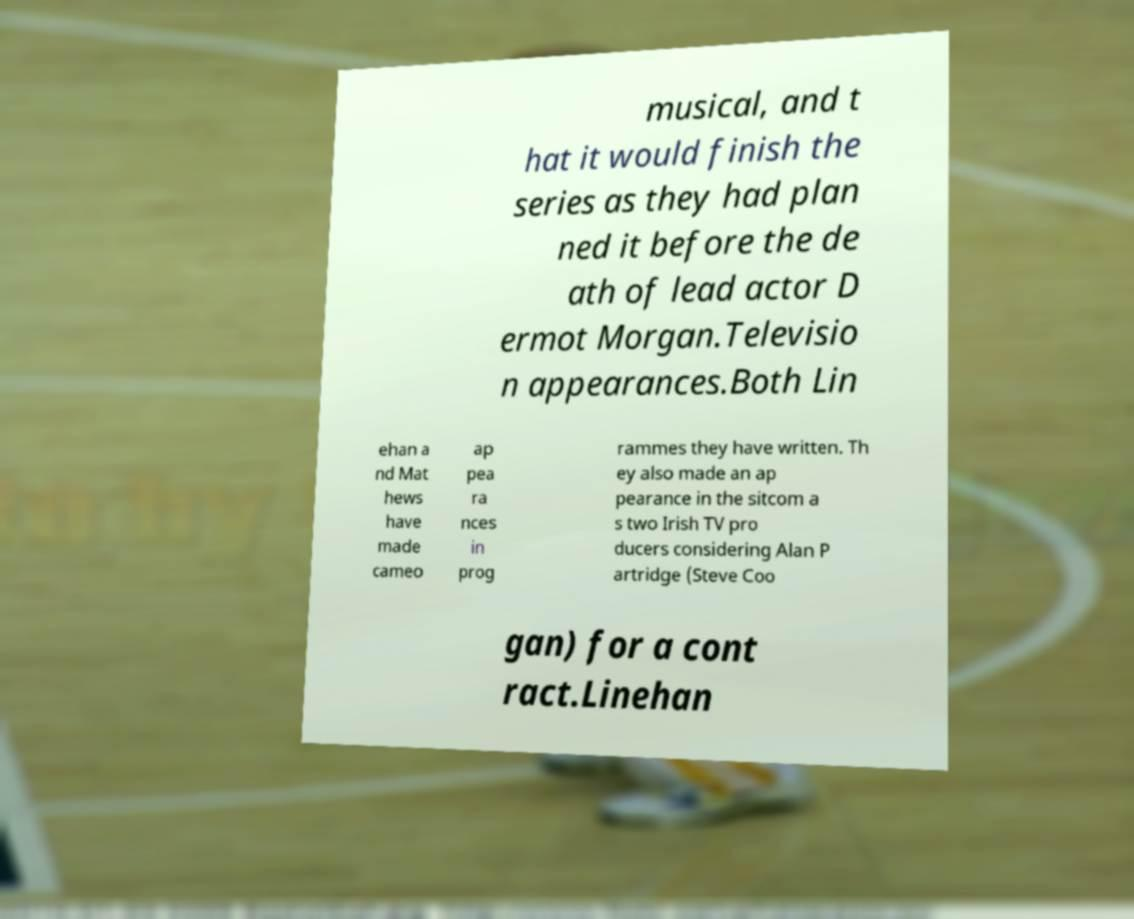Please identify and transcribe the text found in this image. musical, and t hat it would finish the series as they had plan ned it before the de ath of lead actor D ermot Morgan.Televisio n appearances.Both Lin ehan a nd Mat hews have made cameo ap pea ra nces in prog rammes they have written. Th ey also made an ap pearance in the sitcom a s two Irish TV pro ducers considering Alan P artridge (Steve Coo gan) for a cont ract.Linehan 